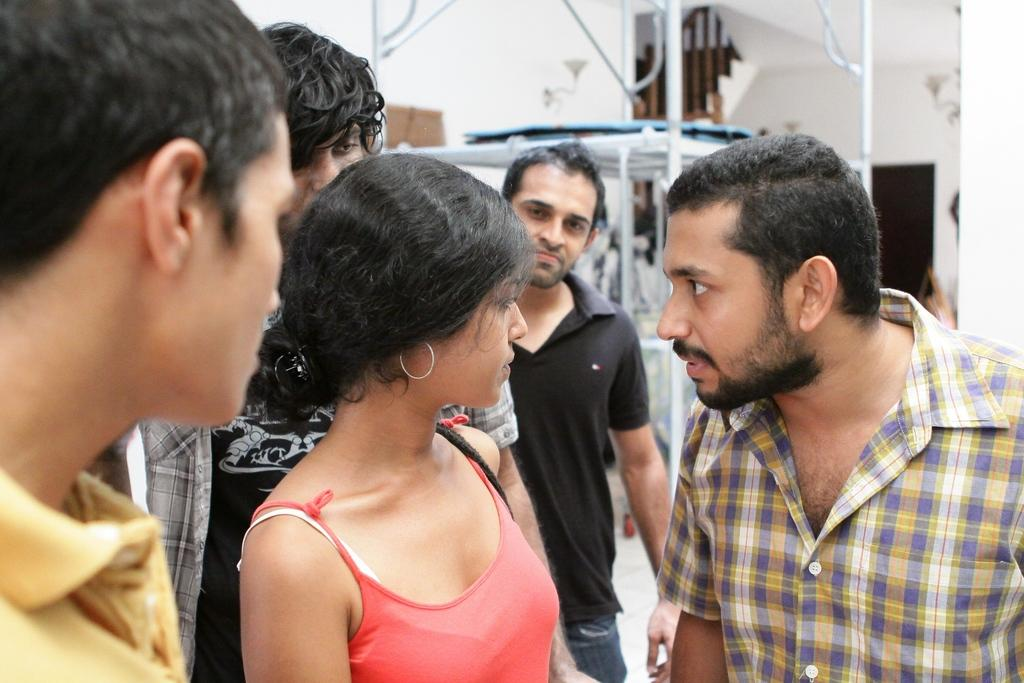How many people are in the image? There is a group of people standing in the image. What can be seen in the background of the image? In the background of the image, there is a stall, poles, lights, a building, a staircase, and a door. Can you describe the building in the background? The building in the background is not described in detail, but it is mentioned as part of the background. What type of hat is the person in the image wearing? There is no mention of a hat or any person wearing a hat in the image. 